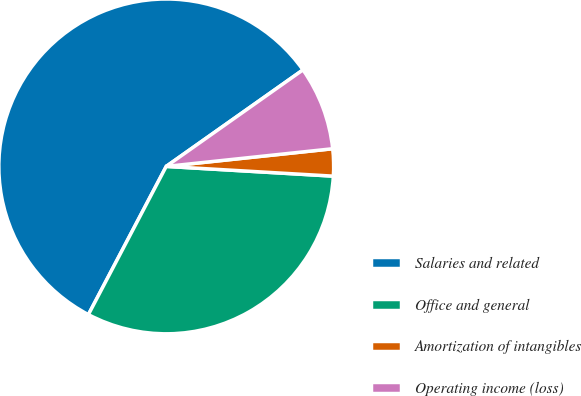Convert chart. <chart><loc_0><loc_0><loc_500><loc_500><pie_chart><fcel>Salaries and related<fcel>Office and general<fcel>Amortization of intangibles<fcel>Operating income (loss)<nl><fcel>57.52%<fcel>31.77%<fcel>2.61%<fcel>8.1%<nl></chart> 